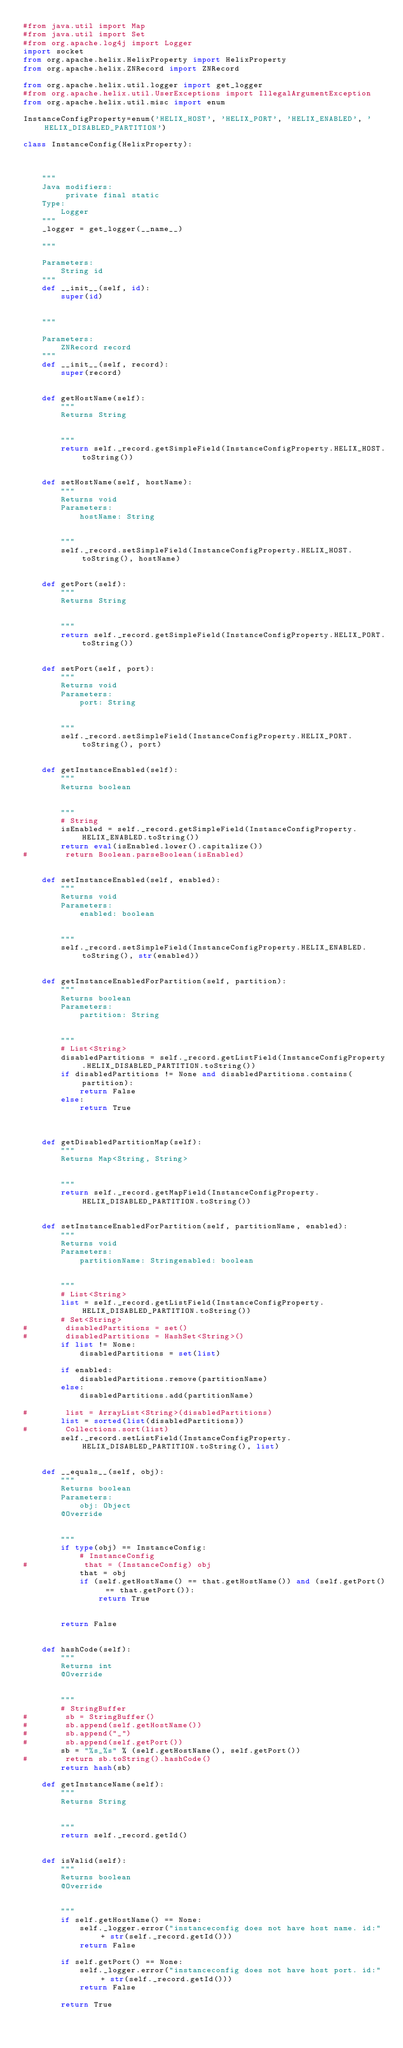Convert code to text. <code><loc_0><loc_0><loc_500><loc_500><_Python_>#from java.util import Map
#from java.util import Set
#from org.apache.log4j import Logger
import socket
from org.apache.helix.HelixProperty import HelixProperty
from org.apache.helix.ZNRecord import ZNRecord

from org.apache.helix.util.logger import get_logger
#from org.apache.helix.util.UserExceptions import IllegalArgumentException
from org.apache.helix.util.misc import enum

InstanceConfigProperty=enum('HELIX_HOST', 'HELIX_PORT', 'HELIX_ENABLED', 'HELIX_DISABLED_PARTITION')

class InstanceConfig(HelixProperty):



    """
    Java modifiers:
         private final static
    Type:
        Logger
    """
    _logger = get_logger(__name__)

    """

    Parameters:
        String id
    """
    def __init__(self, id):
        super(id)


    """

    Parameters:
        ZNRecord record
    """
    def __init__(self, record):
        super(record)


    def getHostName(self):
        """
        Returns String


        """
        return self._record.getSimpleField(InstanceConfigProperty.HELIX_HOST.toString())


    def setHostName(self, hostName):
        """
        Returns void
        Parameters:
            hostName: String


        """
        self._record.setSimpleField(InstanceConfigProperty.HELIX_HOST.toString(), hostName)


    def getPort(self):
        """
        Returns String


        """
        return self._record.getSimpleField(InstanceConfigProperty.HELIX_PORT.toString())


    def setPort(self, port):
        """
        Returns void
        Parameters:
            port: String


        """
        self._record.setSimpleField(InstanceConfigProperty.HELIX_PORT.toString(), port)


    def getInstanceEnabled(self):
        """
        Returns boolean


        """
        # String
        isEnabled = self._record.getSimpleField(InstanceConfigProperty.HELIX_ENABLED.toString())
        return eval(isEnabled.lower().capitalize())
#        return Boolean.parseBoolean(isEnabled)


    def setInstanceEnabled(self, enabled):
        """
        Returns void
        Parameters:
            enabled: boolean


        """
        self._record.setSimpleField(InstanceConfigProperty.HELIX_ENABLED.toString(), str(enabled))


    def getInstanceEnabledForPartition(self, partition):
        """
        Returns boolean
        Parameters:
            partition: String


        """
        # List<String>
        disabledPartitions = self._record.getListField(InstanceConfigProperty.HELIX_DISABLED_PARTITION.toString())
        if disabledPartitions != None and disabledPartitions.contains(partition): 
            return False
        else:
            return True



    def getDisabledPartitionMap(self):
        """
        Returns Map<String, String>


        """
        return self._record.getMapField(InstanceConfigProperty.HELIX_DISABLED_PARTITION.toString())


    def setInstanceEnabledForPartition(self, partitionName, enabled):
        """
        Returns void
        Parameters:
            partitionName: Stringenabled: boolean


        """
        # List<String>
        list = self._record.getListField(InstanceConfigProperty.HELIX_DISABLED_PARTITION.toString())
        # Set<String>
#        disabledPartitions = set()
#        disabledPartitions = HashSet<String>()
        if list != None:
            disabledPartitions = set(list)

        if enabled: 
            disabledPartitions.remove(partitionName)
        else:
            disabledPartitions.add(partitionName)

#        list = ArrayList<String>(disabledPartitions)
        list = sorted(list(disabledPartitions))
#        Collections.sort(list)
        self._record.setListField(InstanceConfigProperty.HELIX_DISABLED_PARTITION.toString(), list)


    def __equals__(self, obj):
        """
        Returns boolean
        Parameters:
            obj: Object
        @Override


        """
        if type(obj) == InstanceConfig: 
            # InstanceConfig
#            that = (InstanceConfig) obj
            that = obj
            if (self.getHostName() == that.getHostName()) and (self.getPort() == that.getPort()):
                return True


        return False


    def hashCode(self):
        """
        Returns int
        @Override


        """
        # StringBuffer
#        sb = StringBuffer()
#        sb.append(self.getHostName())
#        sb.append("_")
#        sb.append(self.getPort())
        sb = "%s_%s" % (self.getHostName(), self.getPort())
#        return sb.toString().hashCode()
        return hash(sb)

    def getInstanceName(self):
        """
        Returns String


        """
        return self._record.getId()


    def isValid(self):
        """
        Returns boolean
        @Override


        """
        if self.getHostName() == None:
            self._logger.error("instanceconfig does not have host name. id:" + str(self._record.getId()))
            return False

        if self.getPort() == None:
            self._logger.error("instanceconfig does not have host port. id:" + str(self._record.getId()))
            return False

        return True



</code> 